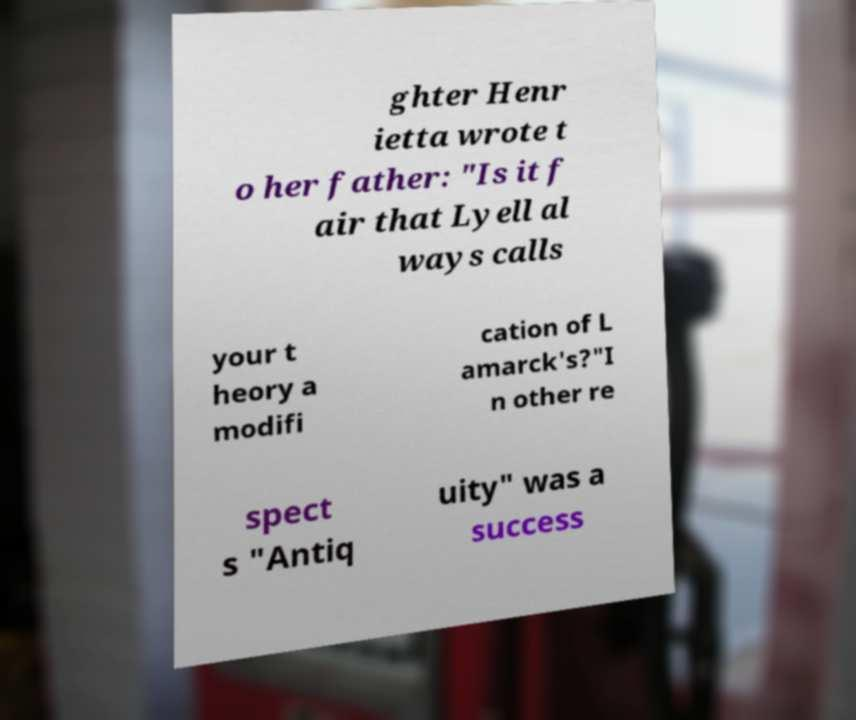Could you assist in decoding the text presented in this image and type it out clearly? ghter Henr ietta wrote t o her father: "Is it f air that Lyell al ways calls your t heory a modifi cation of L amarck's?"I n other re spect s "Antiq uity" was a success 